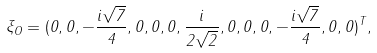Convert formula to latex. <formula><loc_0><loc_0><loc_500><loc_500>\xi _ { O } = ( 0 , 0 , - \frac { i \sqrt { 7 } } { 4 } , 0 , 0 , 0 , \frac { i } { 2 \sqrt { 2 } } , 0 , 0 , 0 , - \frac { i \sqrt { 7 } } { 4 } , 0 , 0 ) ^ { T } ,</formula> 